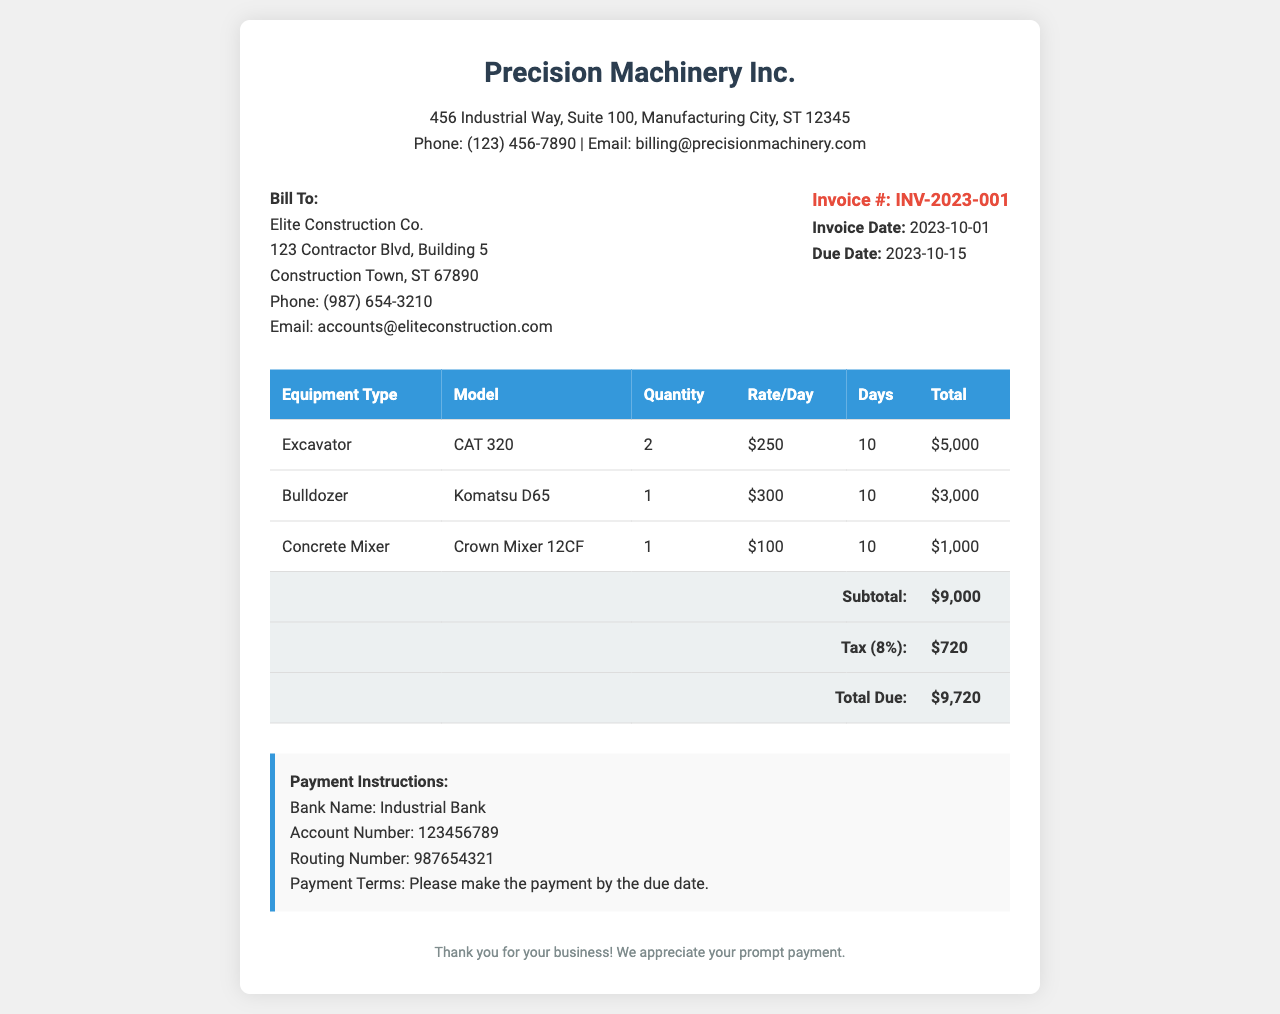What is the invoice number? The invoice number can be found in the document under invoice details.
Answer: INV-2023-001 What is the total due amount? The total due amount is the final calculation at the bottom of the invoice after the subtotal and tax are listed.
Answer: $9,720 Who is the recipient of the invoice? The recipient's name can be found at the top of the invoice section labeled "Bill To."
Answer: Elite Construction Co How many days was the excavator rented? The number of days for the excavator rental is listed in the corresponding row of the invoice table.
Answer: 10 What is the tax rate applied to the total? The tax rate can be inferred from the line item labeled "Tax" on the invoice.
Answer: 8% What equipment type has the highest total cost? To find the equipment type with the highest total, you can compare the total values listed in the last column of the table.
Answer: Excavator What is the due date for the payment? The due date is specified in the invoice details section of the document.
Answer: 2023-10-15 What payment deadline is indicated? The payment deadline is specified in the payment instructions section of the document.
Answer: By the due date What is the rate per day for the concrete mixer? The rate per day for the concrete mixer is found in the invoice table under the "Rate/Day" column for that equipment type.
Answer: $100 